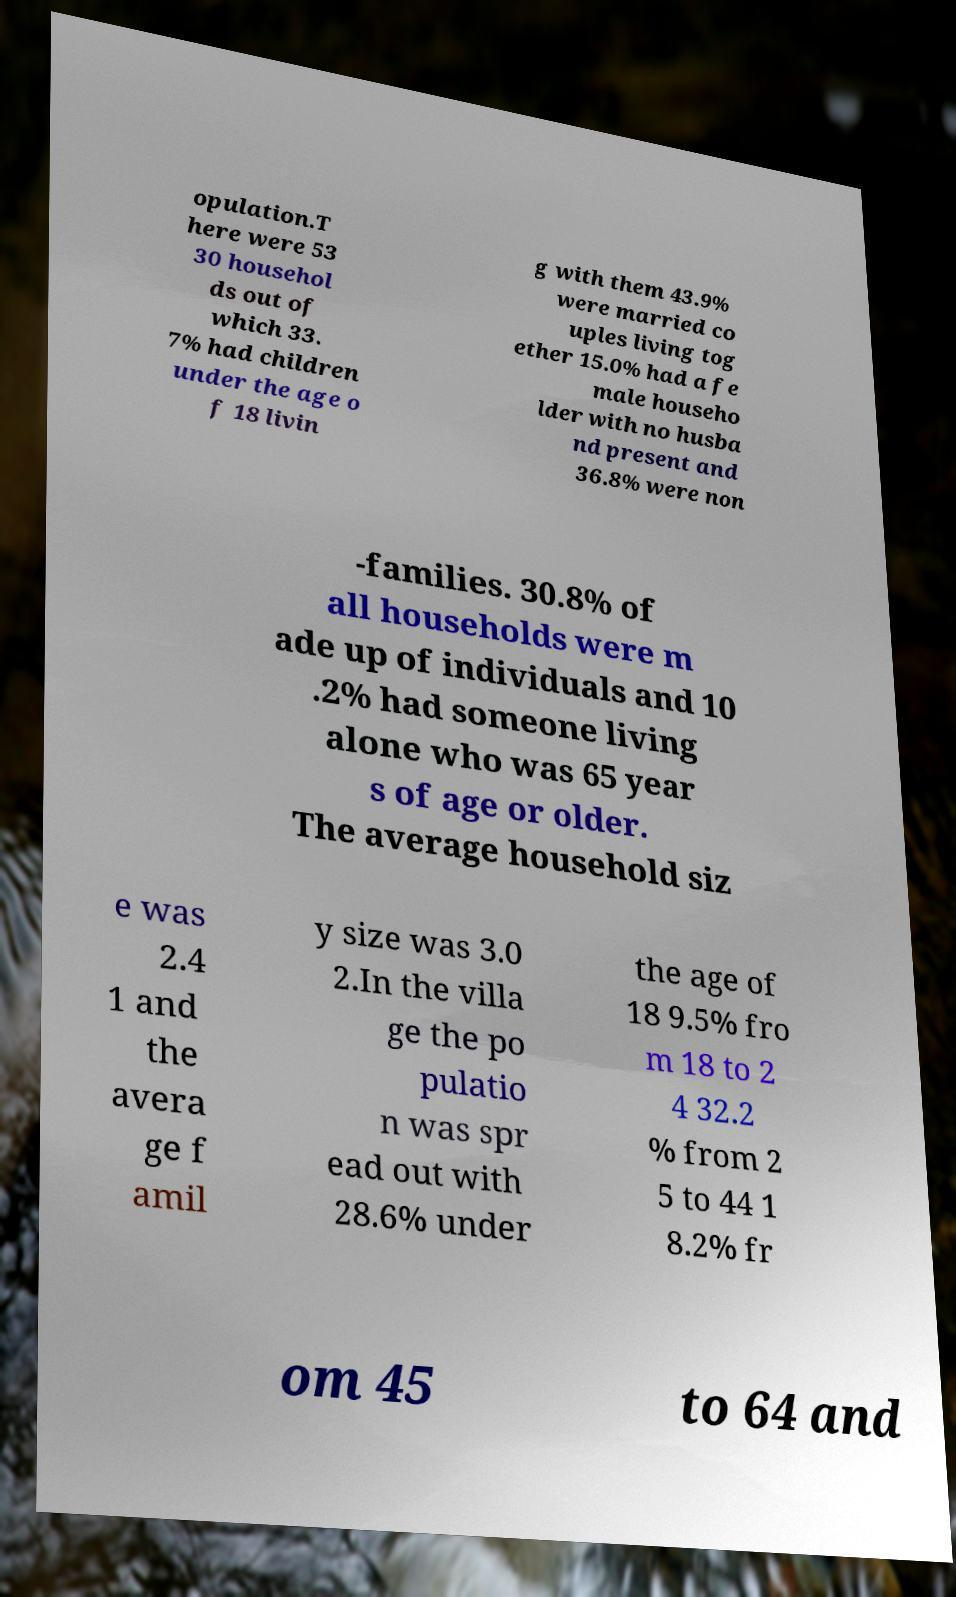Can you read and provide the text displayed in the image?This photo seems to have some interesting text. Can you extract and type it out for me? opulation.T here were 53 30 househol ds out of which 33. 7% had children under the age o f 18 livin g with them 43.9% were married co uples living tog ether 15.0% had a fe male househo lder with no husba nd present and 36.8% were non -families. 30.8% of all households were m ade up of individuals and 10 .2% had someone living alone who was 65 year s of age or older. The average household siz e was 2.4 1 and the avera ge f amil y size was 3.0 2.In the villa ge the po pulatio n was spr ead out with 28.6% under the age of 18 9.5% fro m 18 to 2 4 32.2 % from 2 5 to 44 1 8.2% fr om 45 to 64 and 